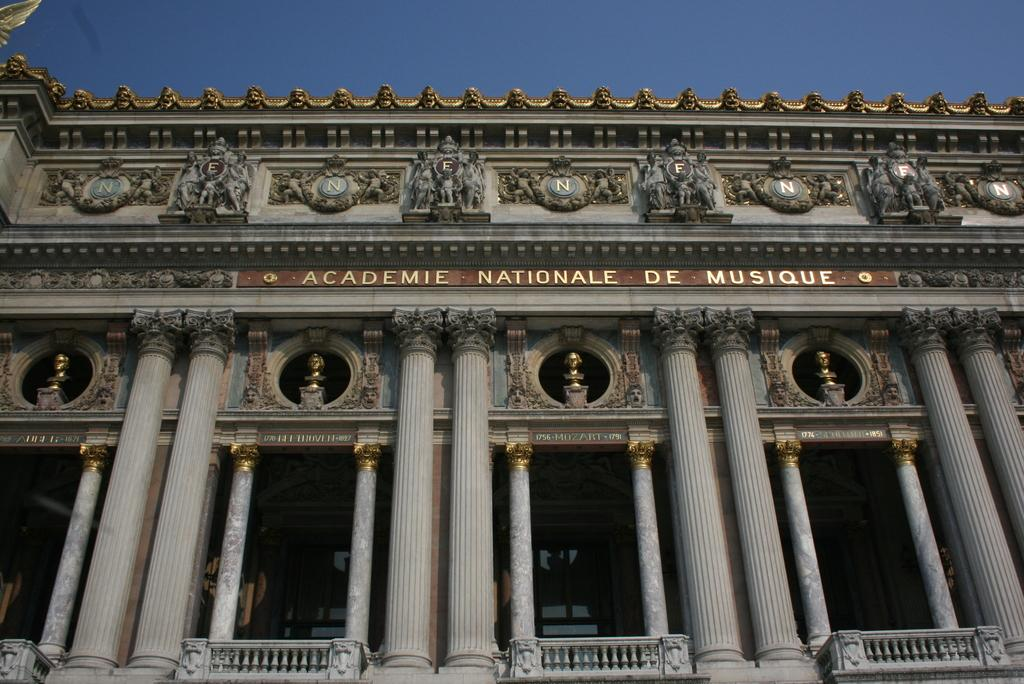What type of structure is visible in the image? There is a building in the image. What architectural features can be seen on the building? The building has pillars and sculptures. What is the color of the sky in the image? The sky is blue in color. Can you see a coil of wire on the building in the image? There is no coil of wire visible on the building in the image. Is there a person standing next to the building in the image? The image does not show any people, only the building with its architectural features. 